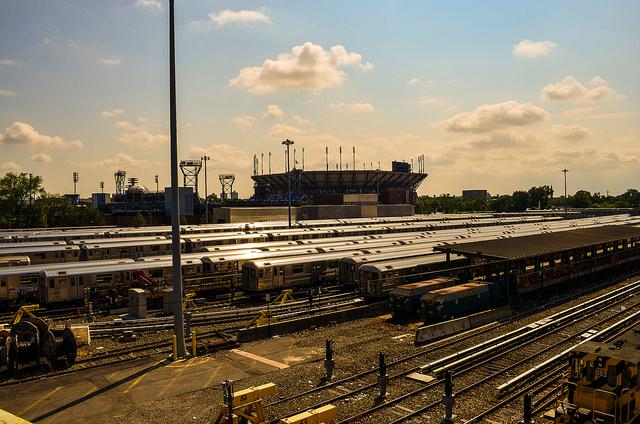Is it raining?
Concise answer only. No. Are these trains moving?
Be succinct. No. What vehicle is on the tracks?
Be succinct. Train. 